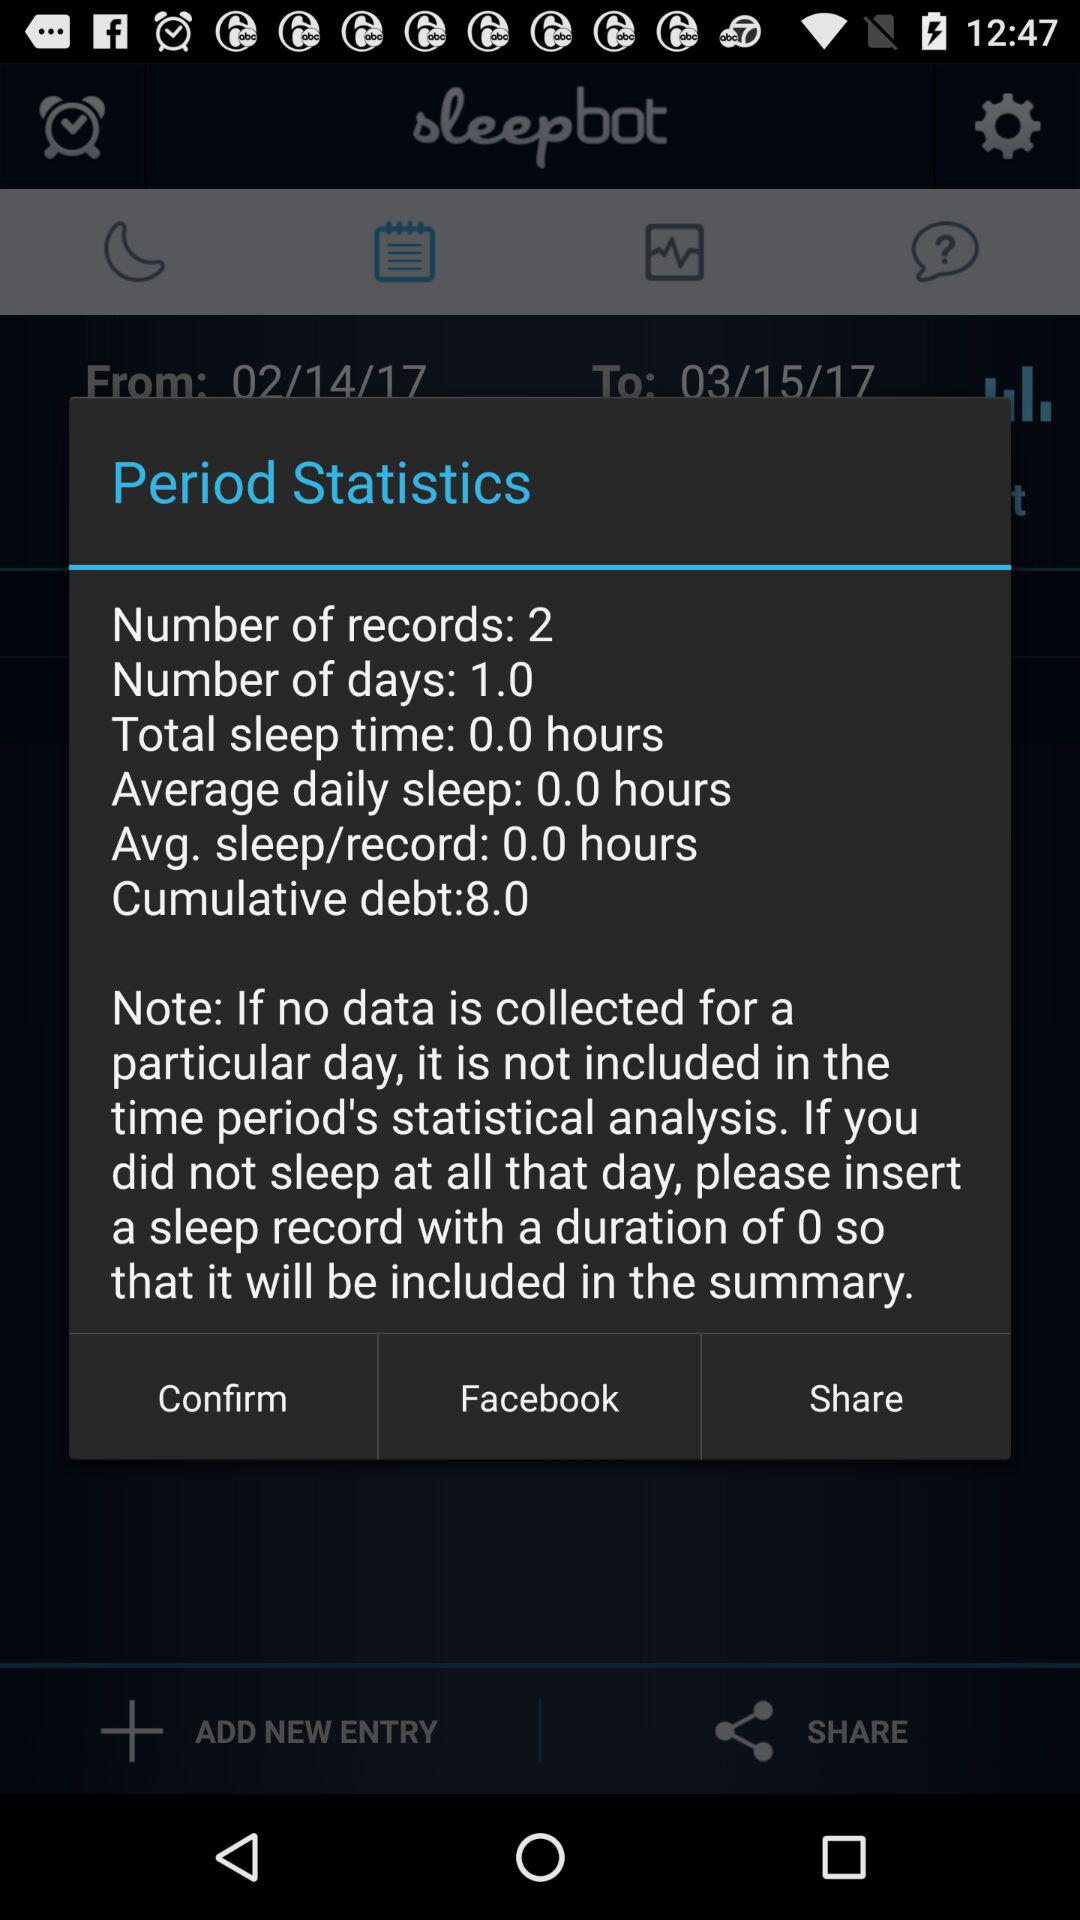What is the number of records? The number of records is 2. 